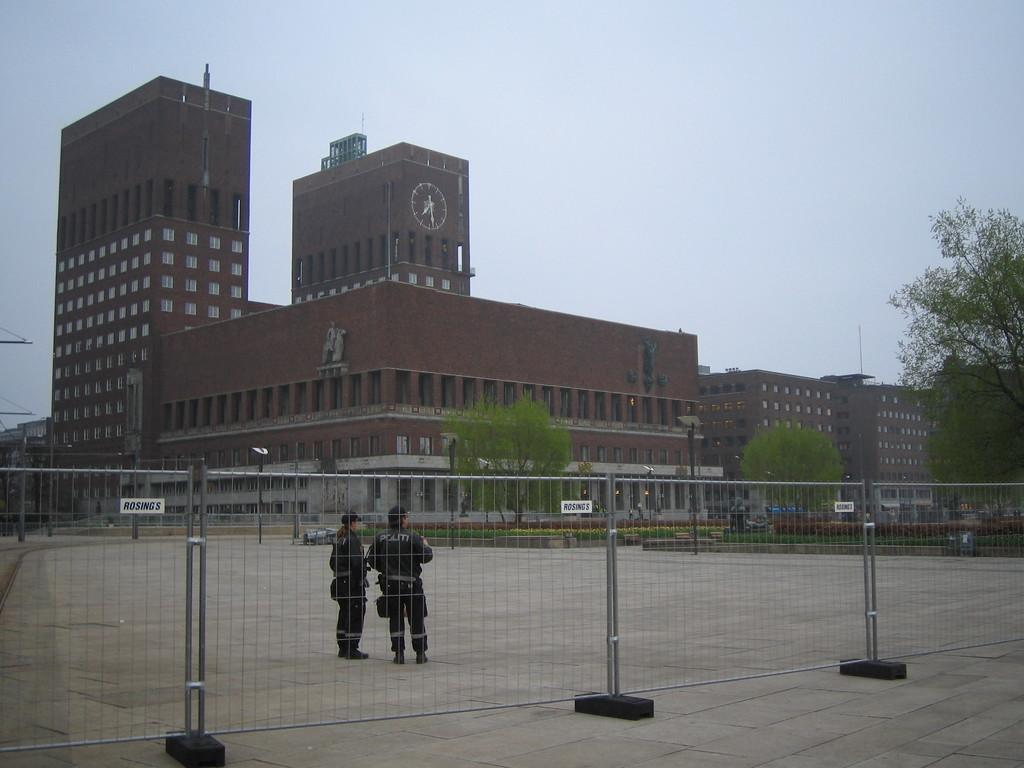What is present in the image that separates or encloses an area? There is a fence in the image. How many people can be seen on the ground in the image? There are two people on the ground in the image. What can be seen in the distance in the image? There are buildings, trees, and poles in the background of the image. What part of the natural environment is visible in the image? The sky is visible in the background of the image. What part of the fence is starting to rust in the image? There is no indication of rust or any other damage to the fence in the image. How many ducks are visible in the image? There are no ducks present in the image. 